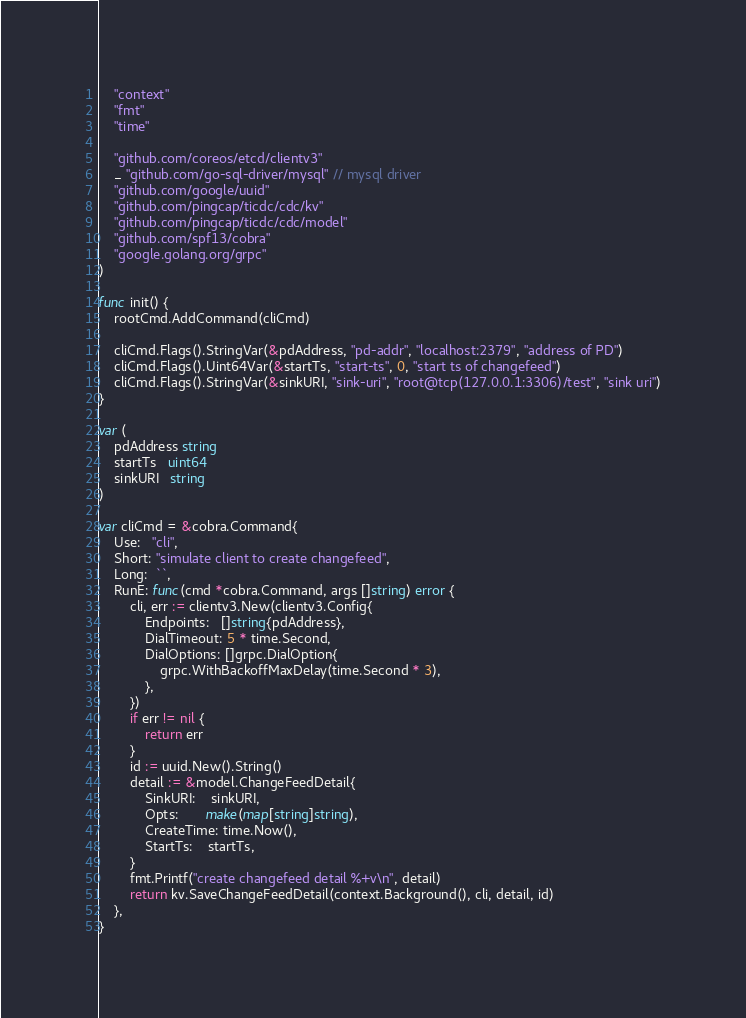<code> <loc_0><loc_0><loc_500><loc_500><_Go_>	"context"
	"fmt"
	"time"

	"github.com/coreos/etcd/clientv3"
	_ "github.com/go-sql-driver/mysql" // mysql driver
	"github.com/google/uuid"
	"github.com/pingcap/ticdc/cdc/kv"
	"github.com/pingcap/ticdc/cdc/model"
	"github.com/spf13/cobra"
	"google.golang.org/grpc"
)

func init() {
	rootCmd.AddCommand(cliCmd)

	cliCmd.Flags().StringVar(&pdAddress, "pd-addr", "localhost:2379", "address of PD")
	cliCmd.Flags().Uint64Var(&startTs, "start-ts", 0, "start ts of changefeed")
	cliCmd.Flags().StringVar(&sinkURI, "sink-uri", "root@tcp(127.0.0.1:3306)/test", "sink uri")
}

var (
	pdAddress string
	startTs   uint64
	sinkURI   string
)

var cliCmd = &cobra.Command{
	Use:   "cli",
	Short: "simulate client to create changefeed",
	Long:  ``,
	RunE: func(cmd *cobra.Command, args []string) error {
		cli, err := clientv3.New(clientv3.Config{
			Endpoints:   []string{pdAddress},
			DialTimeout: 5 * time.Second,
			DialOptions: []grpc.DialOption{
				grpc.WithBackoffMaxDelay(time.Second * 3),
			},
		})
		if err != nil {
			return err
		}
		id := uuid.New().String()
		detail := &model.ChangeFeedDetail{
			SinkURI:    sinkURI,
			Opts:       make(map[string]string),
			CreateTime: time.Now(),
			StartTs:    startTs,
		}
		fmt.Printf("create changefeed detail %+v\n", detail)
		return kv.SaveChangeFeedDetail(context.Background(), cli, detail, id)
	},
}
</code> 